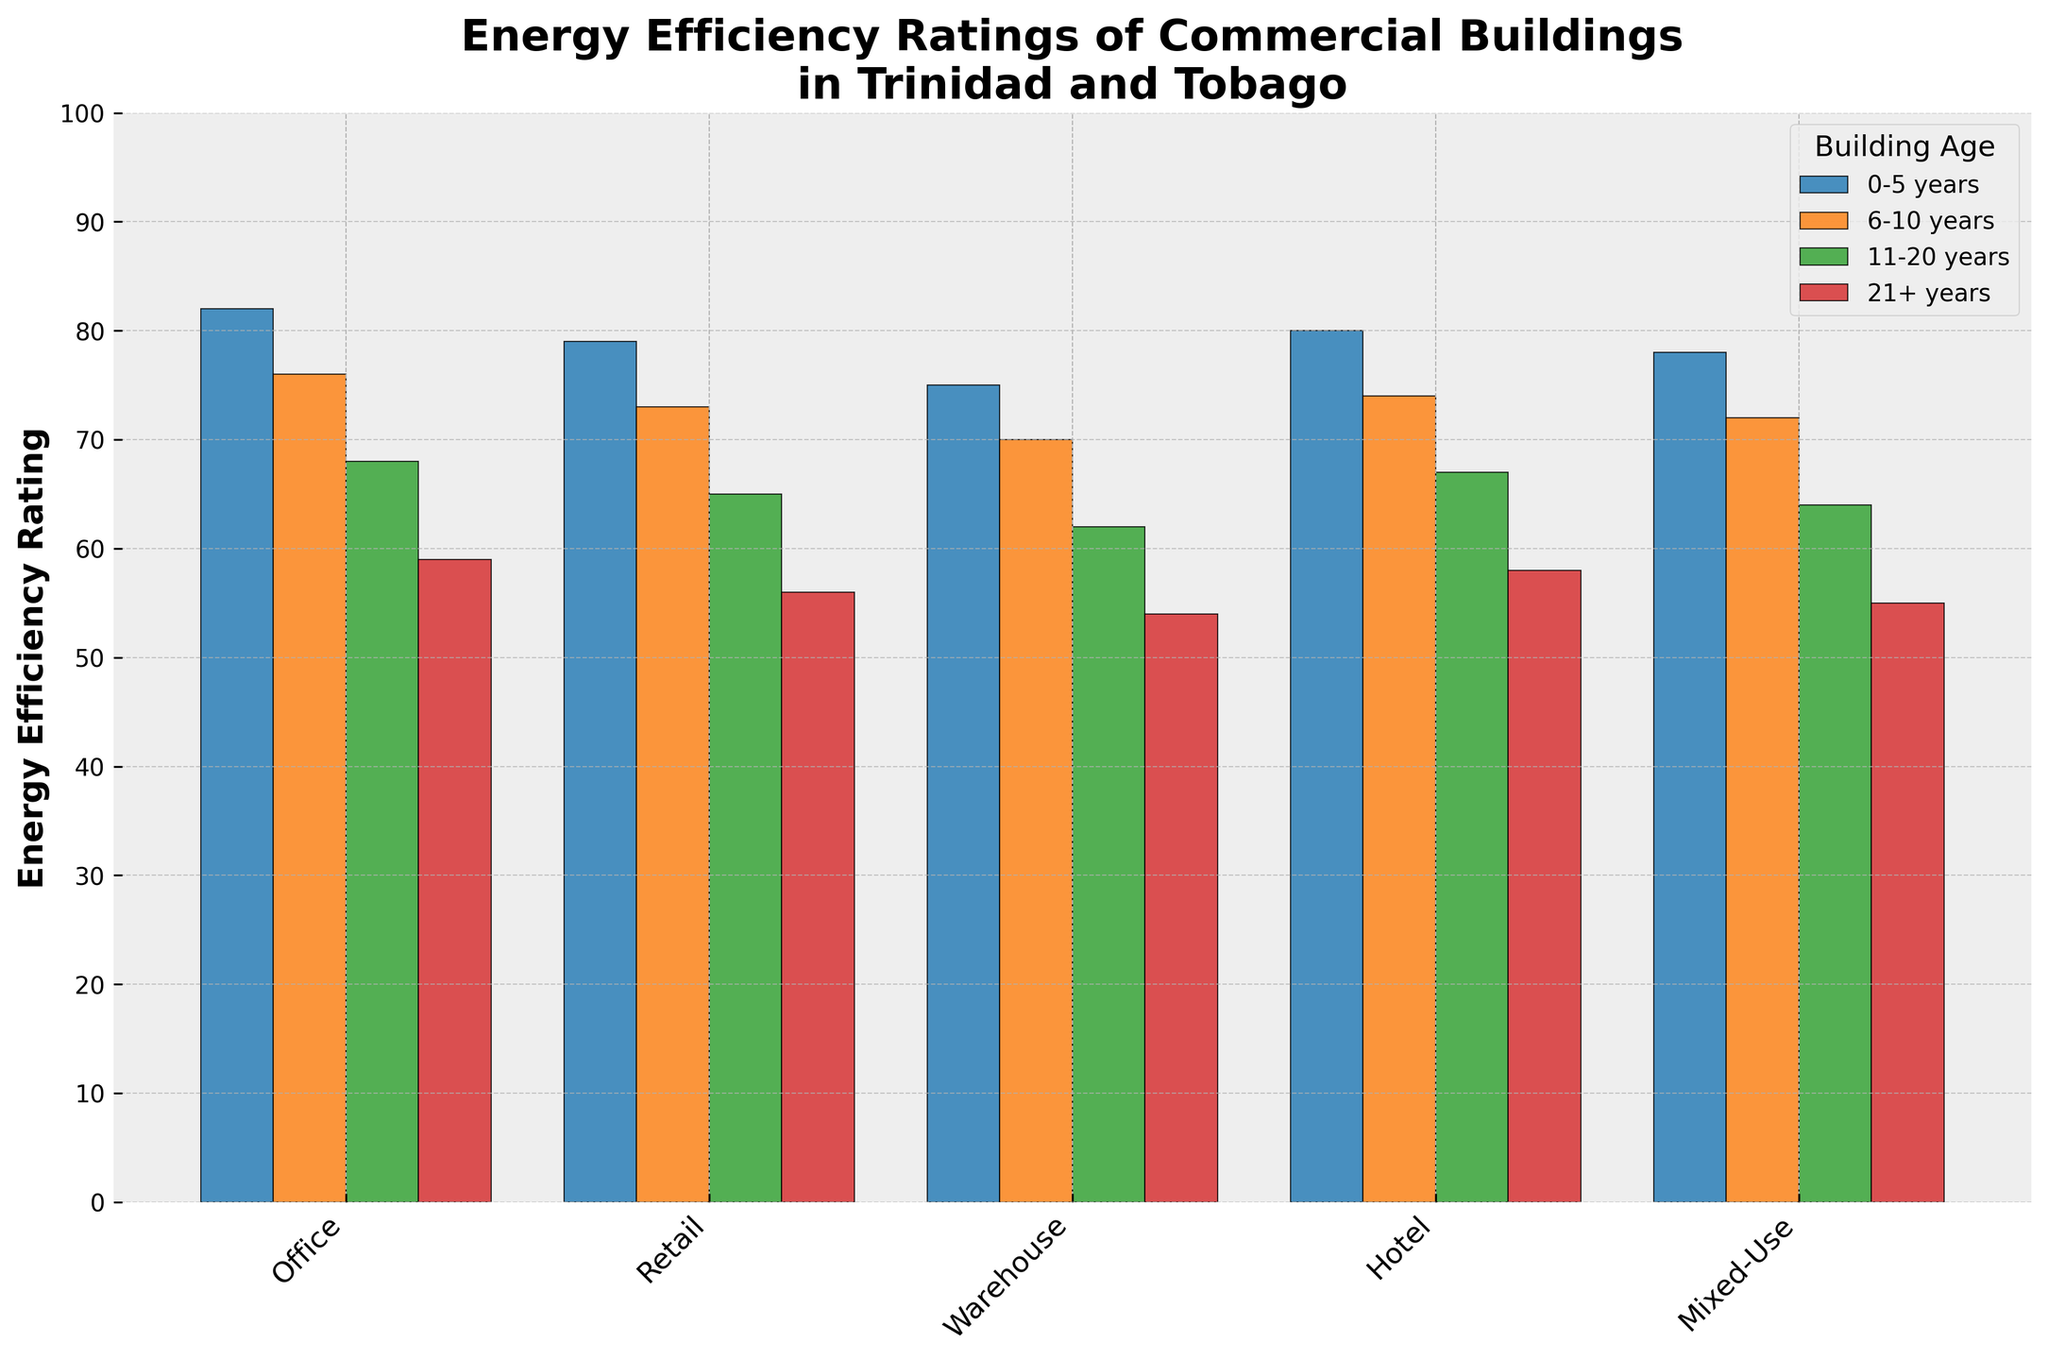Which building type has the highest energy efficiency rating for buildings aged 0-5 years? The highest bar in the section for buildings aged 0-5 years indicates the building type with the highest rating. The height of the bar for Office buildings in this age group is the highest at a rating of 82.
Answer: Office Which building type has the lowest energy efficiency rating for buildings aged 21+ years? The lowest bar in the section for buildings aged 21+ years indicates the building type with the lowest rating. The height of the bar for Warehouse buildings in this age group is the lowest at a rating of 54.
Answer: Warehouse What is the difference in energy efficiency rating between Office buildings aged 0-5 years and 21+ years? Subtract the energy efficiency rating of Office buildings aged 21+ years from that of Office buildings aged 0-5 years: 82 (0-5 years) - 59 (21+ years).
Answer: 23 Which age group generally has the highest energy efficiency ratings across all building types? The bars representing buildings aged 0-5 years are generally the highest across all building types when compared to other age groups.
Answer: 0-5 years What is the average energy efficiency rating for Mixed-Use buildings across all age groups? Add the energy efficiency ratings for Mixed-Use buildings across all age groups and divide by the number of groups: (78 + 72 + 64 + 55) / 4 = 67.25.
Answer: 67.25 How does the energy efficiency rating of Hotel buildings aged 11-20 years compare to Retail buildings aged 11-20 years? Look at the height of the bars for each building type in the 11-20 years age group. Hotel buildings have a rating of 67 while Retail buildings have a rating of 65. Therefore, Hotel buildings have a slightly higher rating.
Answer: Hotel buildings have a slightly higher rating By how much does the rating of the Warehouse buildings decrease as they age from 0-5 years to 21+ years? Subtract the energy efficiency rating of Warehouse buildings aged 21+ years from that of Warehouse buildings aged 0-5 years: 75 (0-5 years) - 54 (21+ years).
Answer: 21 Which age group shows the steepest decline in energy efficiency rating for Office buildings as they age? Calculate the difference in ratings between consecutive age groups for Office buildings: (82 - 76) = 6, (76 - 68) = 8, and (68 - 59) = 9. The steepest decline happens between the 11-20 years and 21+ years age groups with a difference of 9.
Answer: 11-20 years to 21+ years What is the color of the bars representing the energy efficiency ratings of buildings aged 6-10 years? The bars representing the energy efficiency ratings of buildings aged 6-10 years are all marked in the same color, which is orange.
Answer: Orange 